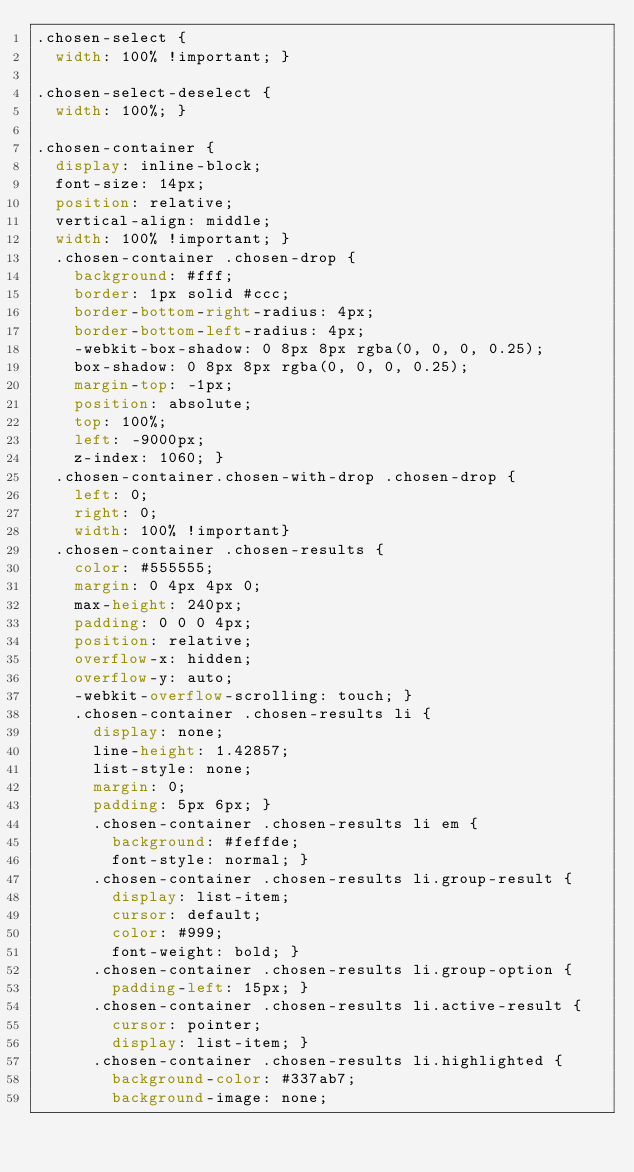Convert code to text. <code><loc_0><loc_0><loc_500><loc_500><_CSS_>.chosen-select {
  width: 100% !important; }

.chosen-select-deselect {
  width: 100%; }

.chosen-container {
  display: inline-block;
  font-size: 14px;
  position: relative;
  vertical-align: middle;
  width: 100% !important; }
  .chosen-container .chosen-drop {
    background: #fff;
    border: 1px solid #ccc;
    border-bottom-right-radius: 4px;
    border-bottom-left-radius: 4px;
    -webkit-box-shadow: 0 8px 8px rgba(0, 0, 0, 0.25);
    box-shadow: 0 8px 8px rgba(0, 0, 0, 0.25);
    margin-top: -1px;
    position: absolute;
    top: 100%;
    left: -9000px;
    z-index: 1060; }
  .chosen-container.chosen-with-drop .chosen-drop {
    left: 0;
    right: 0;
    width: 100% !important}
  .chosen-container .chosen-results {
    color: #555555;
    margin: 0 4px 4px 0;
    max-height: 240px;
    padding: 0 0 0 4px;
    position: relative;
    overflow-x: hidden;
    overflow-y: auto;
    -webkit-overflow-scrolling: touch; }
    .chosen-container .chosen-results li {
      display: none;
      line-height: 1.42857;
      list-style: none;
      margin: 0;
      padding: 5px 6px; }
      .chosen-container .chosen-results li em {
        background: #feffde;
        font-style: normal; }
      .chosen-container .chosen-results li.group-result {
        display: list-item;
        cursor: default;
        color: #999;
        font-weight: bold; }
      .chosen-container .chosen-results li.group-option {
        padding-left: 15px; }
      .chosen-container .chosen-results li.active-result {
        cursor: pointer;
        display: list-item; }
      .chosen-container .chosen-results li.highlighted {
        background-color: #337ab7;
        background-image: none;</code> 